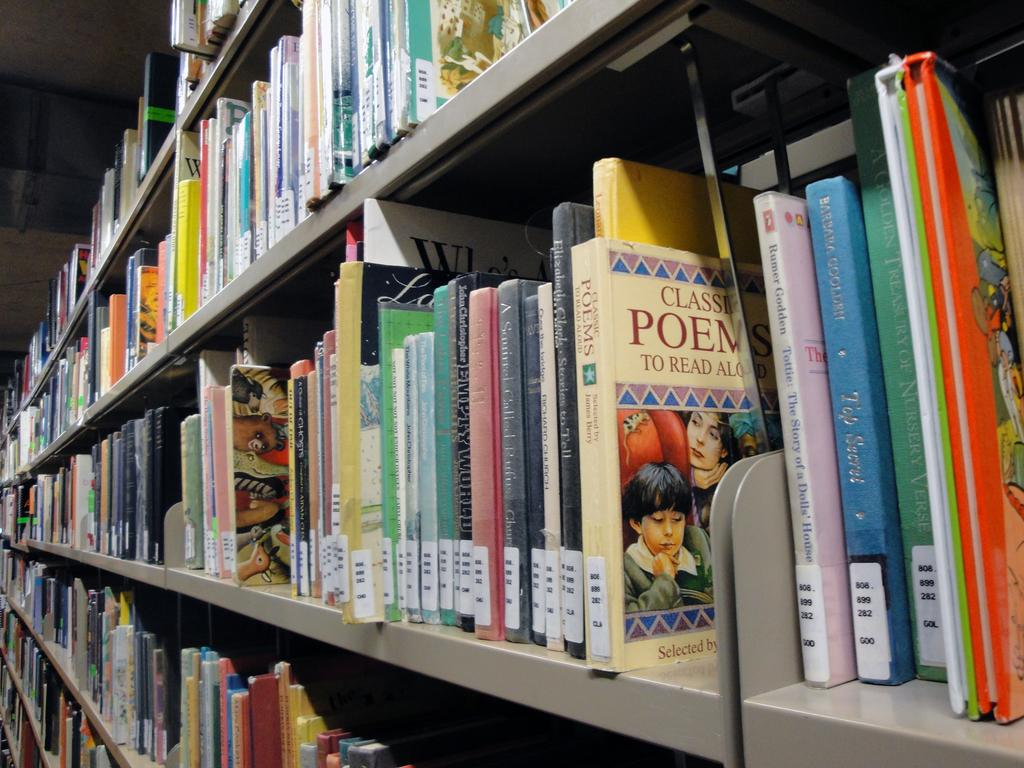What is the main subject of the image? The main subject of the image is many books. How are the books arranged in the image? The books are in racks in the image. What can be said about the appearance of the books? The books are colorful in the image. Can you see a plane flying over the books in the image? There is no plane visible in the image; it only features books in racks. 